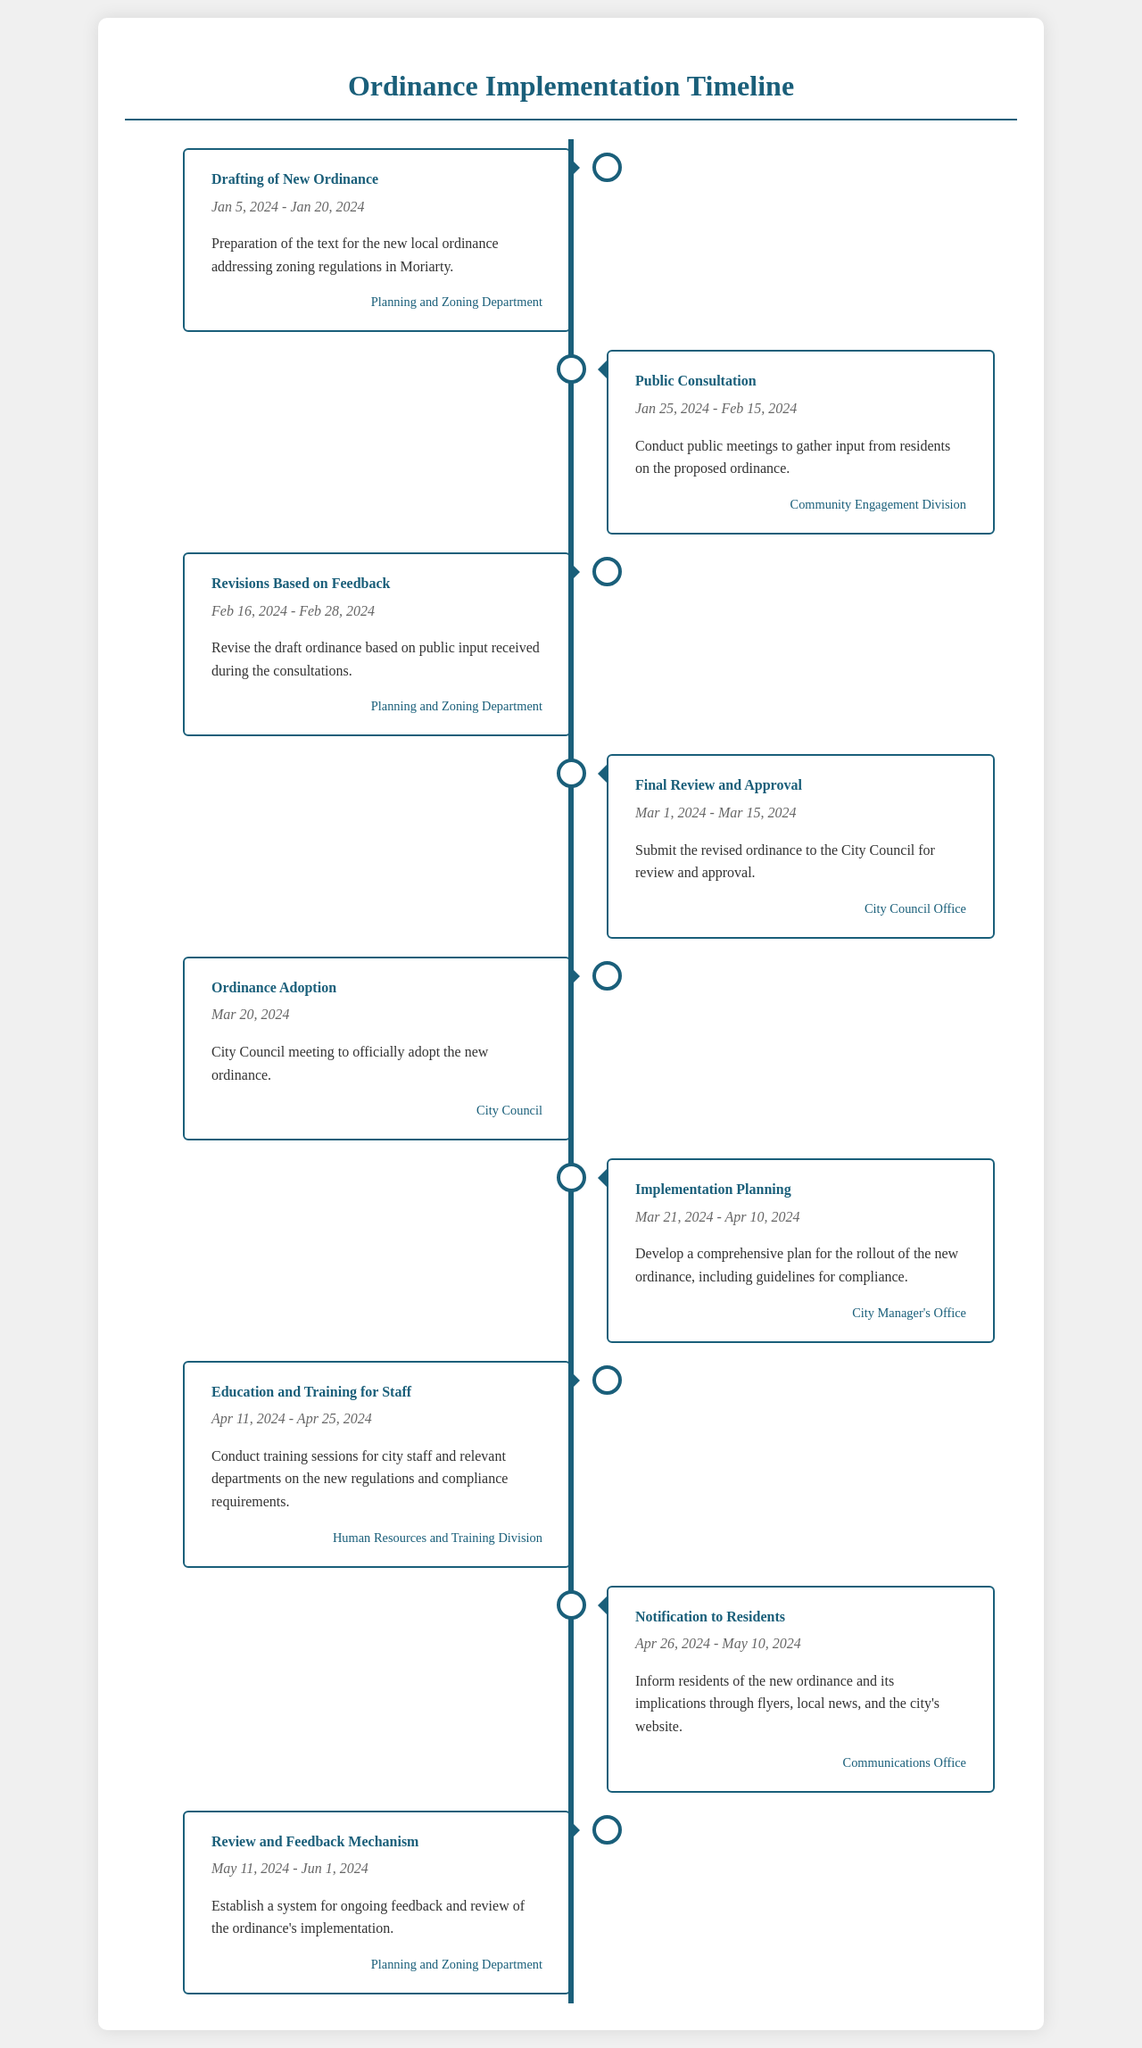What is the first task in the timeline? The first task listed is "Drafting of New Ordinance" as per the timeline.
Answer: Drafting of New Ordinance What are the dates for public consultation? The document specifies that public consultation will take place from January 25, 2024, to February 15, 2024.
Answer: Jan 25, 2024 - Feb 15, 2024 Which department is responsible for revisions based on feedback? The department tasked with revisions based on feedback is the Planning and Zoning Department according to the timeline.
Answer: Planning and Zoning Department On what date is the ordinance adoption scheduled? The document indicates that the ordinance adoption is scheduled for March 20, 2024.
Answer: Mar 20, 2024 What is the last task listed in the timeline? The last task mentioned in the timeline is "Review and Feedback Mechanism."
Answer: Review and Feedback Mechanism How long is the training for city staff scheduled to last? The document states that the training for city staff will last from April 11, 2024, to April 25, 2024, which is a total of 15 days.
Answer: 15 days What is the purpose of the task "Implementation Planning"? The implementation planning task involves developing a comprehensive plan for the rollout of the new ordinance, including guidelines for compliance.
Answer: Develop a comprehensive plan Which office is responsible for notifying residents? According to the timeline, the Communications Office is responsible for notifying residents about the new ordinance.
Answer: Communications Office When is the final review and approval of the ordinance scheduled? The final review and approval process for the ordinance is scheduled between March 1, 2024, and March 15, 2024.
Answer: Mar 1, 2024 - Mar 15, 2024 